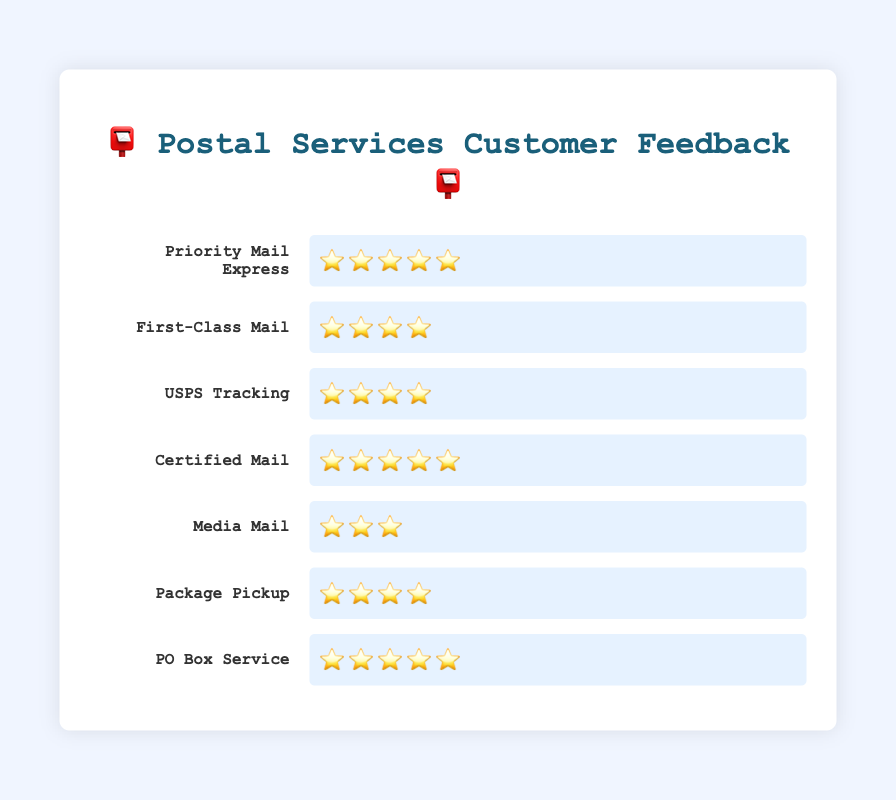Which service has the highest rating? To determine the highest rating, locate the service with the most stars. Priority Mail Express, Certified Mail, and PO Box Service each have five stars.
Answer: Priority Mail Express, Certified Mail, and PO Box Service Which service has the lowest rating? Identify the service with the fewest number of stars. Media Mail has three stars, making it the lowest-rated service.
Answer: Media Mail How many services have a five-star rating? Count the services with five stars. There are three services: Priority Mail Express, Certified Mail, and PO Box Service.
Answer: 3 Compare the ratings of First-Class Mail and Media Mail. Which one is rated higher? First-Class Mail has four stars, while Media Mail has three stars. Therefore, First-Class Mail is rated higher.
Answer: First-Class Mail Calculate the average rating of all services. Convert the emoji ratings to numbers: Priority Mail Express (5), First-Class Mail (4), USPS Tracking (4), Certified Mail (5), Media Mail (3), Package Pickup (4), PO Box Service (5). Sum these ratings (5+4+4+5+3+4+5) to get 30. Divide by the number of services (7) to get the average: 30/7 ≈ 4.29.
Answer: 4.29 Which services share the same rating of four stars? Identify the services with four stars: First-Class Mail, USPS Tracking, and Package Pickup all have four stars.
Answer: First-Class Mail, USPS Tracking, and Package Pickup How many more stars does Priority Mail Express have compared to Media Mail? Priority Mail Express has five stars, and Media Mail has three stars. Subtract Media Mail's stars from Priority Mail Express's stars: 5 - 3 = 2.
Answer: 2 Is the rating for USPS Tracking higher than the rating for Package Pickup? Both USPS Tracking and Package Pickup have four stars. Hence, their ratings are equal, neither higher nor lower.
Answer: No What is the mode (most common) rating among the services? List the number of stars for each service and count the frequencies: 3 (1 time), 4 (3 times), 5 (3 times). Both four and five stars are seen three times, making them the most common.
Answer: 4 and 5 What is the difference between the highest and lowest ratings? The highest rating is five stars, and the lowest is three stars. Subtract the lowest rating from the highest rating: 5 - 3 = 2.
Answer: 2 